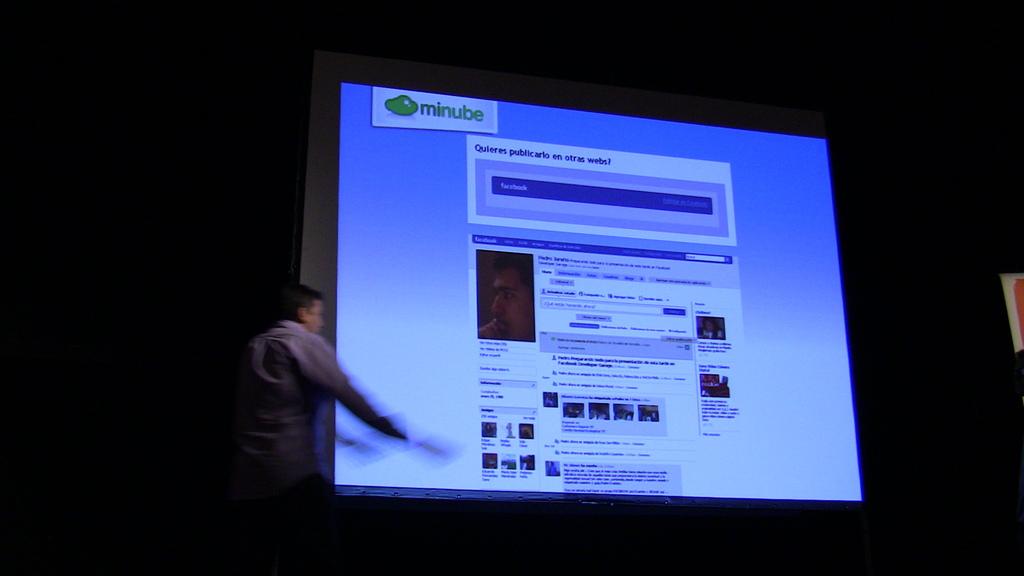What social media website are they using?
Offer a very short reply. Minube. What app is being shown according to the top left of the screen?
Provide a short and direct response. Minube. 